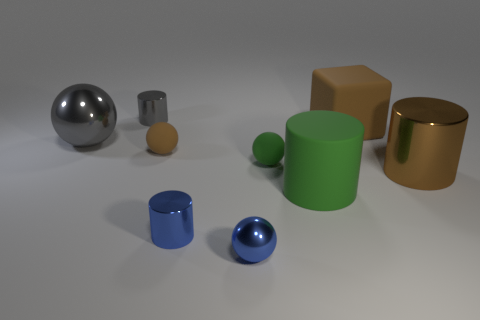What is the material of the object that is the same color as the big rubber cylinder?
Provide a short and direct response. Rubber. What number of matte objects are either big yellow blocks or big brown cylinders?
Offer a very short reply. 0. There is a brown matte thing that is on the right side of the tiny brown object; are there any brown metal objects left of it?
Offer a very short reply. No. Does the cylinder that is on the right side of the green rubber cylinder have the same material as the small gray cylinder?
Your response must be concise. Yes. How many other objects are the same color as the block?
Your response must be concise. 2. Is the matte cylinder the same color as the large metallic cylinder?
Make the answer very short. No. There is a metallic object on the left side of the gray shiny thing that is behind the large gray sphere; what size is it?
Offer a terse response. Large. Does the small sphere that is in front of the green cylinder have the same material as the brown cylinder that is right of the big brown matte object?
Give a very brief answer. Yes. Do the tiny cylinder to the left of the tiny brown matte thing and the large metal ball have the same color?
Your response must be concise. Yes. There is a green cylinder; how many shiny cylinders are to the right of it?
Your response must be concise. 1. 